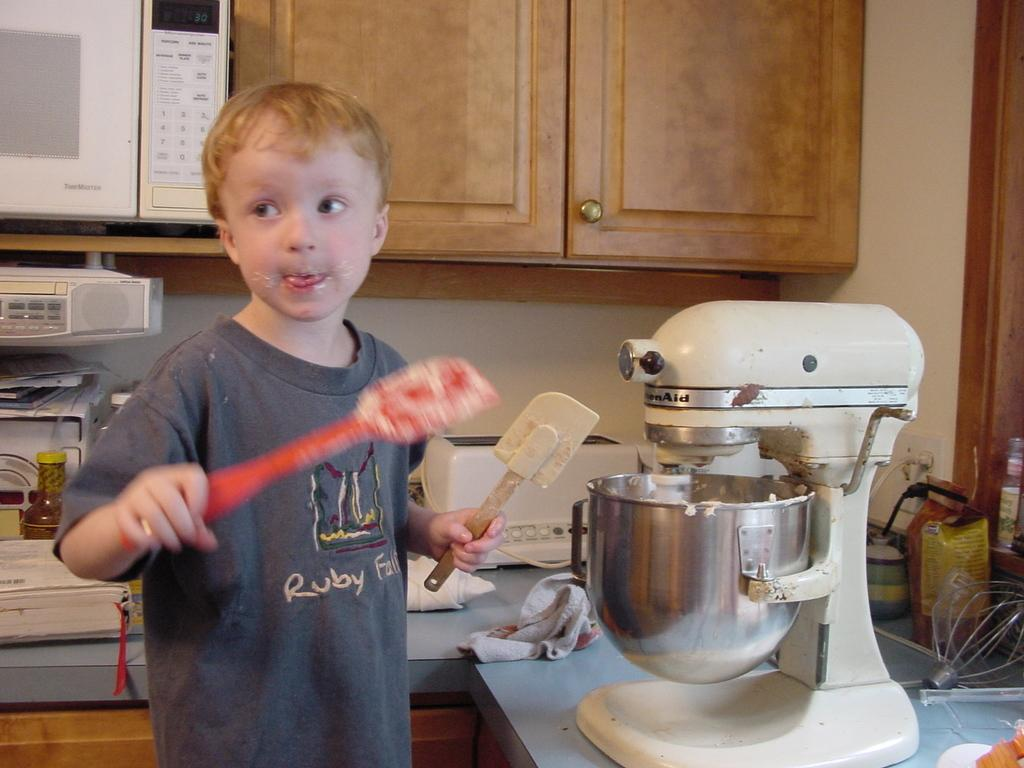<image>
Offer a succinct explanation of the picture presented. The boy playing in the cake batter has a shirt on that says Ruby Falls. 